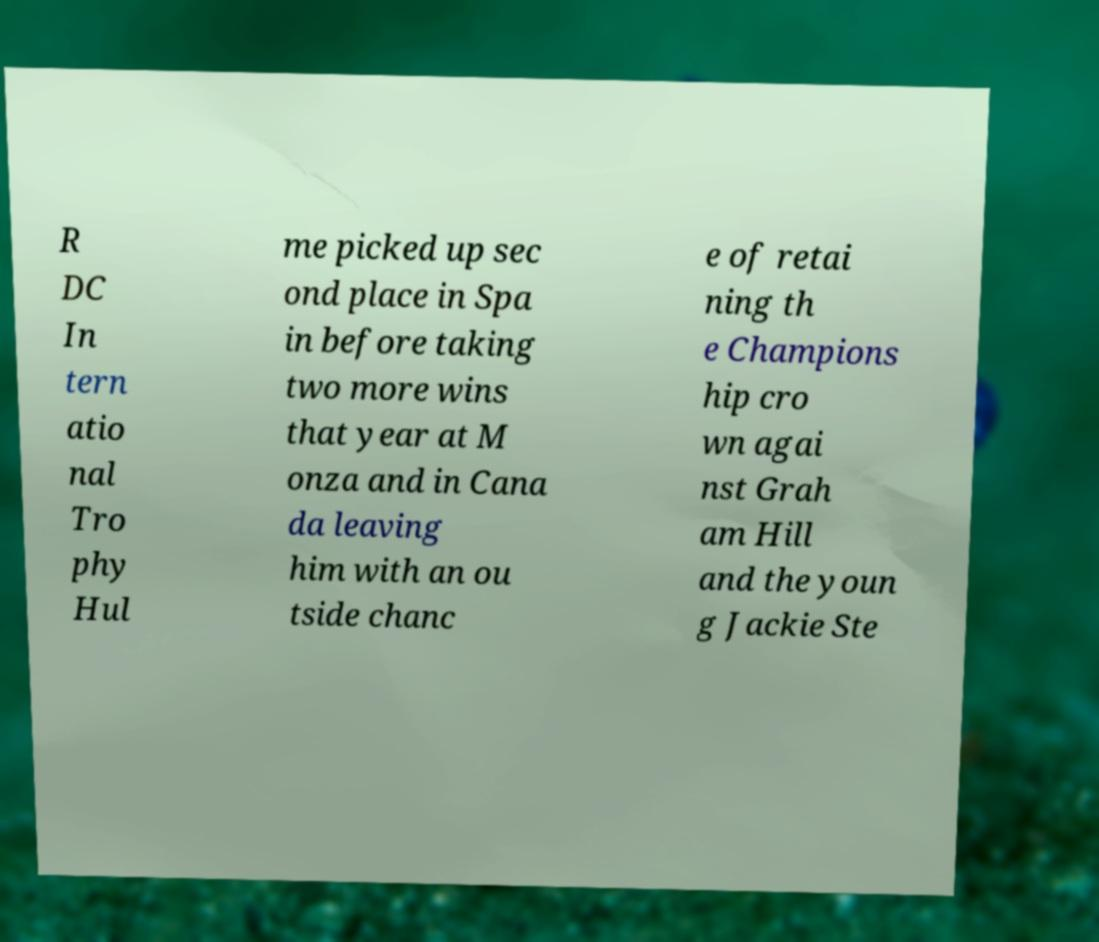What messages or text are displayed in this image? I need them in a readable, typed format. R DC In tern atio nal Tro phy Hul me picked up sec ond place in Spa in before taking two more wins that year at M onza and in Cana da leaving him with an ou tside chanc e of retai ning th e Champions hip cro wn agai nst Grah am Hill and the youn g Jackie Ste 